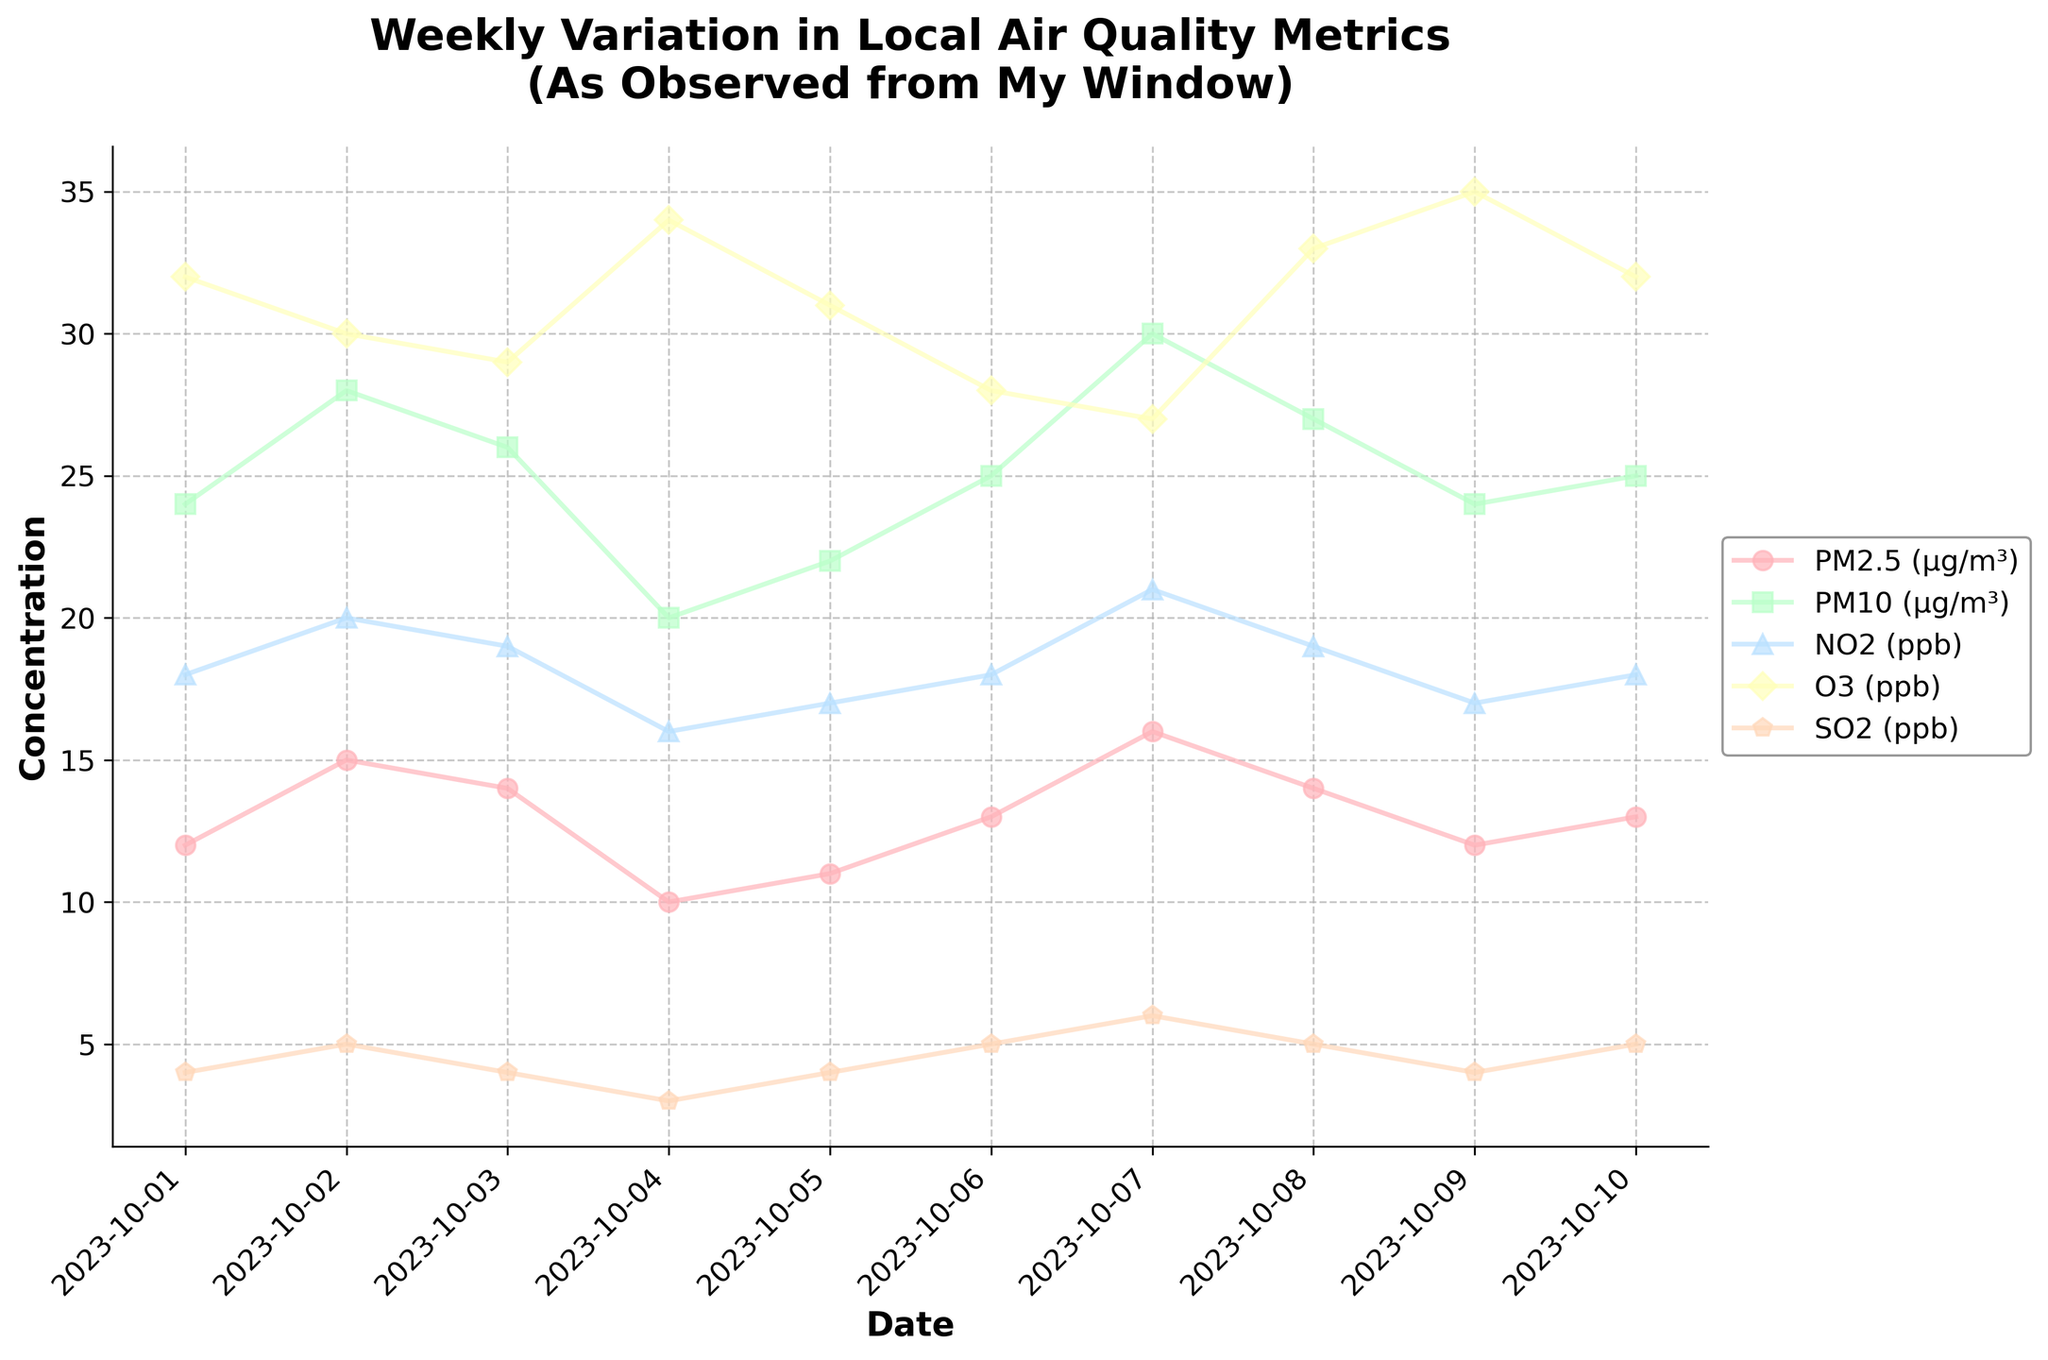What is the title of the plot? The title of the plot is the text that appears at the top of the chart. It helps provide context and an overview of what the data represents. The title in this figure is "Weekly Variation in Local Air Quality Metrics (As Observed from My Window)."
Answer: Weekly Variation in Local Air Quality Metrics (As Observed from My Window) What are the metrics measured in the plot? The metrics are the different pollutants or air quality parameters tracked over time. These are provided in the legend of the plot and include PM2.5, PM10, NO2, O3, and SO2.
Answer: PM2.5, PM10, NO2, O3, SO2 How many data points are there for each metric? Each metric is recorded daily from October 1st to October 10th. By counting the date range, we can see that there are 10 data points for each metric.
Answer: 10 Which air quality metric shows the highest value on October 7th? On October 7th, we refer to the markers for that date on the time series plot. Among the metrics, PM10 shows the highest value of 30 µg/m³.
Answer: PM10 Which day recorded the lowest value for PM2.5 and what was that value? We look at the time series for PM2.5 and identify the day with the lowest point. The lowest value for PM2.5 is 10 µg/m³ on October 4th.
Answer: October 4th, 10 µg/m³ What is the average concentration of O3 over the 10-day period? To find the average, sum up all the O3 values from October 1st to October 10th and divide by the number of days (10). The O3 values are: 32, 30, 29, 34, 31, 28, 27, 33, 35, 32. (32+30+29+34+31+28+27+33+35+32)/10 = 31.1
Answer: 31.1 ppb Which two metrics show a peak on the same day, and what are those peaks? We need to identify days where two different metrics reach their highest values. Both PM2.5 and NO2 peak on October 7th with values of 16 µg/m³ and 21 ppb, respectively.
Answer: PM2.5 and NO2, October 7th How does NO2 on October 6th compare with NO2 on October 2nd? Compare the concentration values of NO2 on these two dates. On October 6th, NO2 is 18 ppb while on October 2nd, it is 20 ppb. NO2 was higher on October 2nd than October 6th.
Answer: Higher on October 2nd What is the overall trend for SO2 concentrations over the 10 days? Examine the time series plot for SO2 and observe how its values change over time. SO2 shows a slight increase, peaking at 6 ppb on October 7th, and then stabilizing.
Answer: Slight increasing trend 